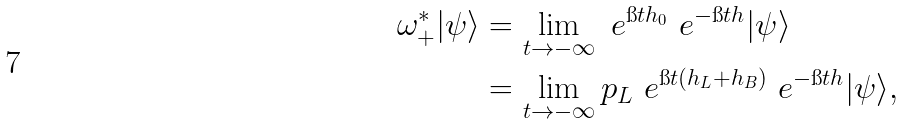Convert formula to latex. <formula><loc_0><loc_0><loc_500><loc_500>\omega _ { + } ^ { \ast } | \psi \rangle & = \lim _ { t \to - \infty } \ e ^ { \i t h _ { 0 } } \ e ^ { - \i t h } | \psi \rangle \\ & = \lim _ { t \to - \infty } p _ { L } \ e ^ { \i t ( h _ { L } + h _ { B } ) } \ e ^ { - \i t h } | \psi \rangle ,</formula> 